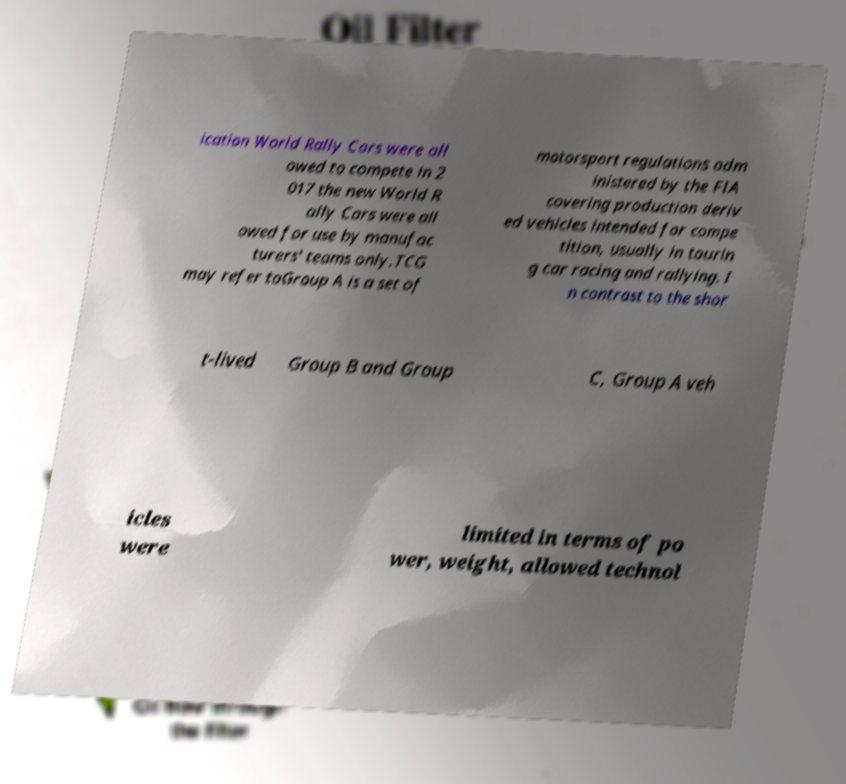Can you read and provide the text displayed in the image?This photo seems to have some interesting text. Can you extract and type it out for me? ication World Rally Cars were all owed to compete in 2 017 the new World R ally Cars were all owed for use by manufac turers' teams only.TCG may refer toGroup A is a set of motorsport regulations adm inistered by the FIA covering production deriv ed vehicles intended for compe tition, usually in tourin g car racing and rallying. I n contrast to the shor t-lived Group B and Group C, Group A veh icles were limited in terms of po wer, weight, allowed technol 